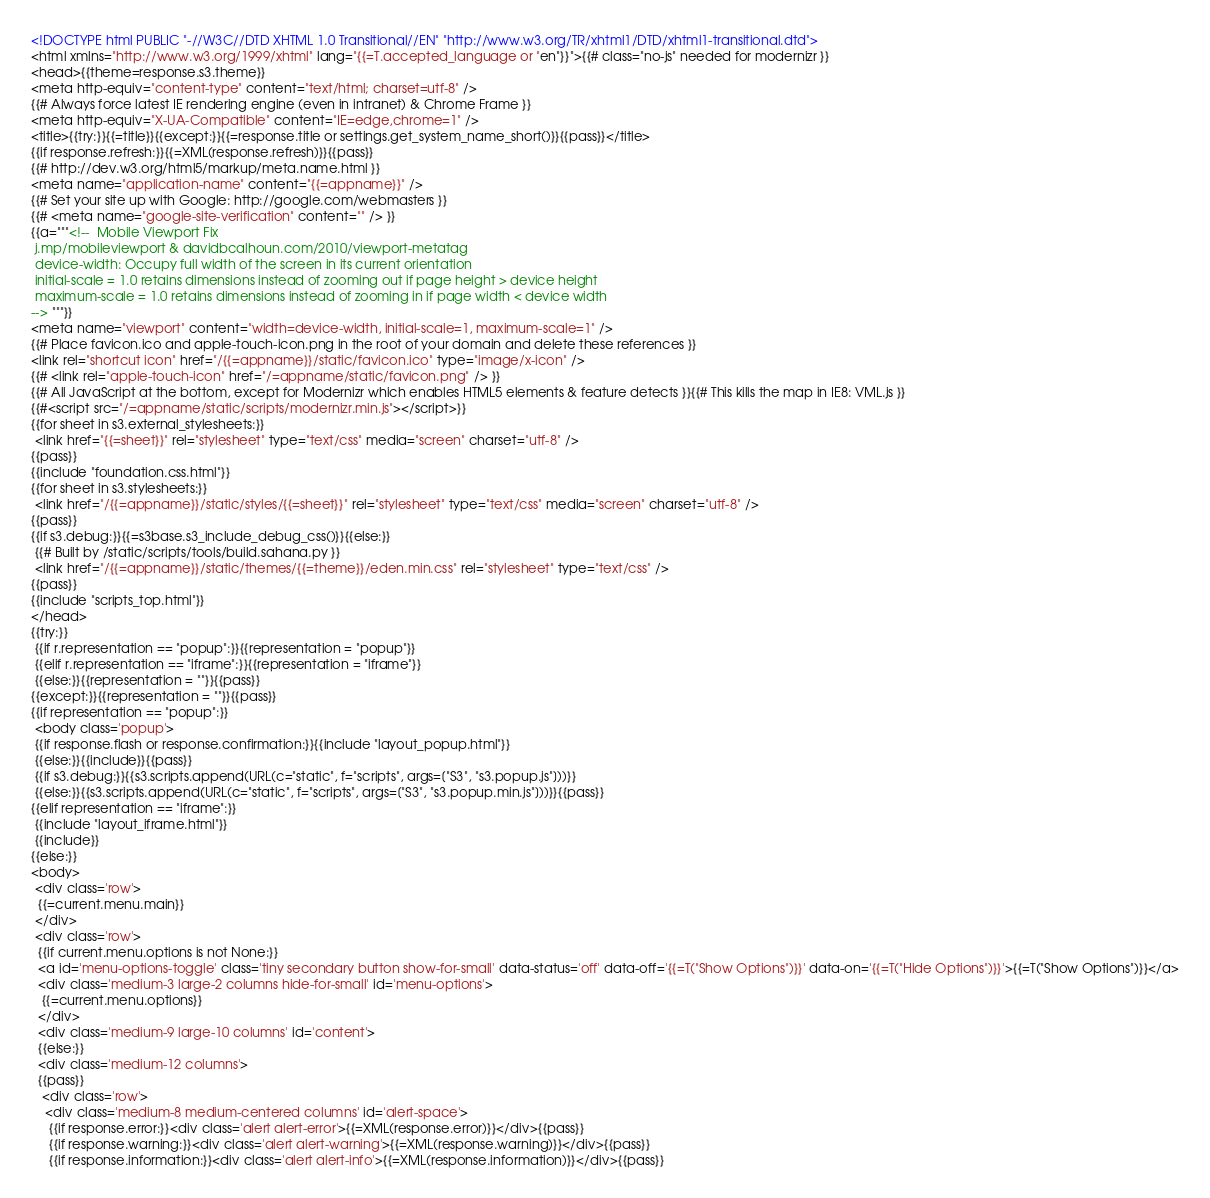Convert code to text. <code><loc_0><loc_0><loc_500><loc_500><_HTML_><!DOCTYPE html PUBLIC "-//W3C//DTD XHTML 1.0 Transitional//EN" "http://www.w3.org/TR/xhtml1/DTD/xhtml1-transitional.dtd">
<html xmlns="http://www.w3.org/1999/xhtml" lang="{{=T.accepted_language or "en"}}">{{# class="no-js" needed for modernizr }}
<head>{{theme=response.s3.theme}}
<meta http-equiv="content-type" content="text/html; charset=utf-8" />
{{# Always force latest IE rendering engine (even in intranet) & Chrome Frame }}
<meta http-equiv="X-UA-Compatible" content="IE=edge,chrome=1" />
<title>{{try:}}{{=title}}{{except:}}{{=response.title or settings.get_system_name_short()}}{{pass}}</title>
{{if response.refresh:}}{{=XML(response.refresh)}}{{pass}}
{{# http://dev.w3.org/html5/markup/meta.name.html }}
<meta name="application-name" content="{{=appname}}" />
{{# Set your site up with Google: http://google.com/webmasters }}
{{# <meta name="google-site-verification" content="" /> }}
{{a="""<!--  Mobile Viewport Fix
 j.mp/mobileviewport & davidbcalhoun.com/2010/viewport-metatag
 device-width: Occupy full width of the screen in its current orientation
 initial-scale = 1.0 retains dimensions instead of zooming out if page height > device height
 maximum-scale = 1.0 retains dimensions instead of zooming in if page width < device width
--> """}}
<meta name="viewport" content="width=device-width, initial-scale=1, maximum-scale=1" />
{{# Place favicon.ico and apple-touch-icon.png in the root of your domain and delete these references }}
<link rel="shortcut icon" href="/{{=appname}}/static/favicon.ico" type="image/x-icon" />
{{# <link rel="apple-touch-icon" href="/=appname/static/favicon.png" /> }}
{{# All JavaScript at the bottom, except for Modernizr which enables HTML5 elements & feature detects }}{{# This kills the map in IE8: VML.js }}
{{#<script src="/=appname/static/scripts/modernizr.min.js"></script>}}
{{for sheet in s3.external_stylesheets:}}
 <link href="{{=sheet}}" rel="stylesheet" type="text/css" media="screen" charset="utf-8" />
{{pass}}
{{include "foundation.css.html"}}
{{for sheet in s3.stylesheets:}}
 <link href="/{{=appname}}/static/styles/{{=sheet}}" rel="stylesheet" type="text/css" media="screen" charset="utf-8" />
{{pass}}
{{if s3.debug:}}{{=s3base.s3_include_debug_css()}}{{else:}}
 {{# Built by /static/scripts/tools/build.sahana.py }}
 <link href="/{{=appname}}/static/themes/{{=theme}}/eden.min.css" rel="stylesheet" type="text/css" />
{{pass}}
{{include "scripts_top.html"}}
</head>
{{try:}}
 {{if r.representation == "popup":}}{{representation = "popup"}}
 {{elif r.representation == "iframe":}}{{representation = "iframe"}}
 {{else:}}{{representation = ""}}{{pass}}
{{except:}}{{representation = ""}}{{pass}}
{{if representation == "popup":}}
 <body class='popup'>
 {{if response.flash or response.confirmation:}}{{include "layout_popup.html"}}
 {{else:}}{{include}}{{pass}}
 {{if s3.debug:}}{{s3.scripts.append(URL(c="static", f="scripts", args=["S3", "s3.popup.js"]))}}
 {{else:}}{{s3.scripts.append(URL(c="static", f="scripts", args=["S3", "s3.popup.min.js"]))}}{{pass}}
{{elif representation == "iframe":}}
 {{include "layout_iframe.html"}}
 {{include}}
{{else:}}
<body>
 <div class='row'>
  {{=current.menu.main}}
 </div>
 <div class='row'>
  {{if current.menu.options is not None:}}
  <a id='menu-options-toggle' class='tiny secondary button show-for-small' data-status='off' data-off='{{=T("Show Options")}}' data-on='{{=T("Hide Options")}}'>{{=T("Show Options")}}</a>
  <div class='medium-3 large-2 columns hide-for-small' id='menu-options'>
   {{=current.menu.options}}
  </div>
  <div class='medium-9 large-10 columns' id='content'>
  {{else:}}
  <div class='medium-12 columns'>
  {{pass}}
   <div class='row'>
    <div class='medium-8 medium-centered columns' id='alert-space'>
     {{if response.error:}}<div class='alert alert-error'>{{=XML(response.error)}}</div>{{pass}}
     {{if response.warning:}}<div class='alert alert-warning'>{{=XML(response.warning)}}</div>{{pass}}
     {{if response.information:}}<div class='alert alert-info'>{{=XML(response.information)}}</div>{{pass}}</code> 